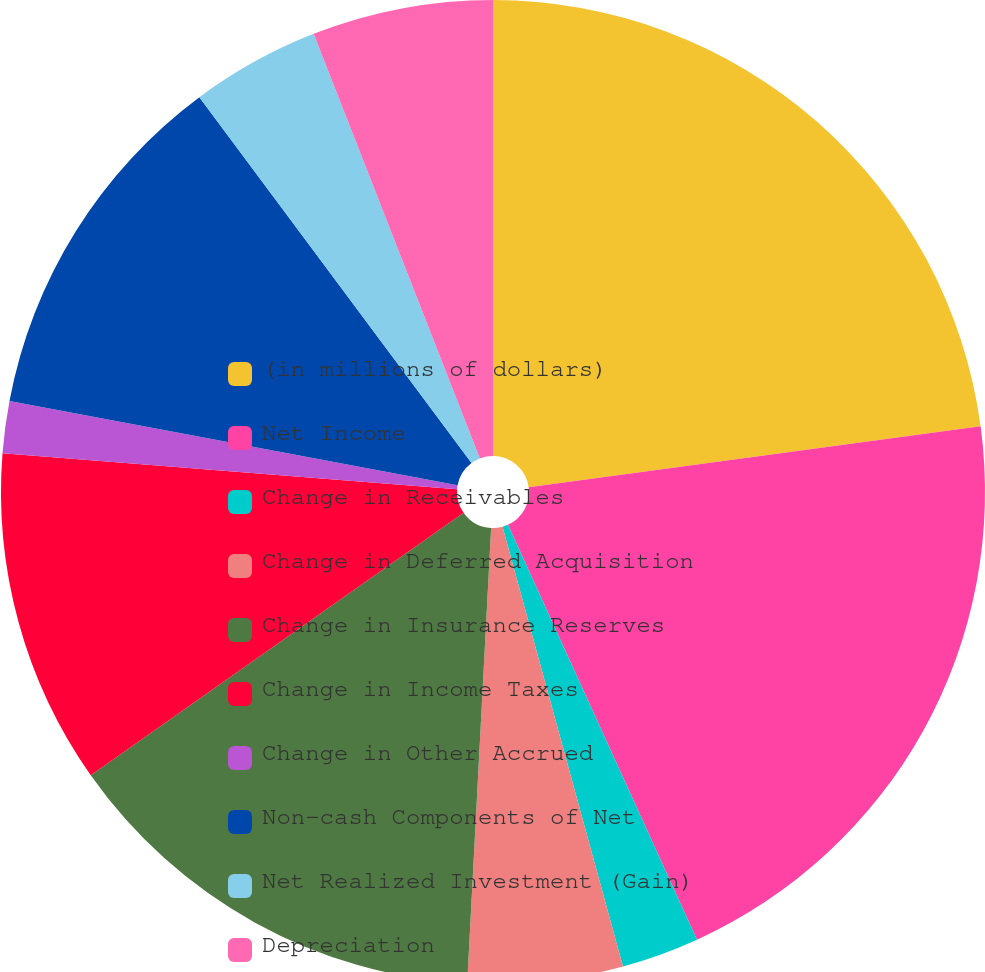Convert chart. <chart><loc_0><loc_0><loc_500><loc_500><pie_chart><fcel>(in millions of dollars)<fcel>Net Income<fcel>Change in Receivables<fcel>Change in Deferred Acquisition<fcel>Change in Insurance Reserves<fcel>Change in Income Taxes<fcel>Change in Other Accrued<fcel>Non-cash Components of Net<fcel>Net Realized Investment (Gain)<fcel>Depreciation<nl><fcel>22.87%<fcel>20.33%<fcel>2.55%<fcel>5.09%<fcel>14.4%<fcel>11.02%<fcel>1.71%<fcel>11.86%<fcel>4.24%<fcel>5.94%<nl></chart> 